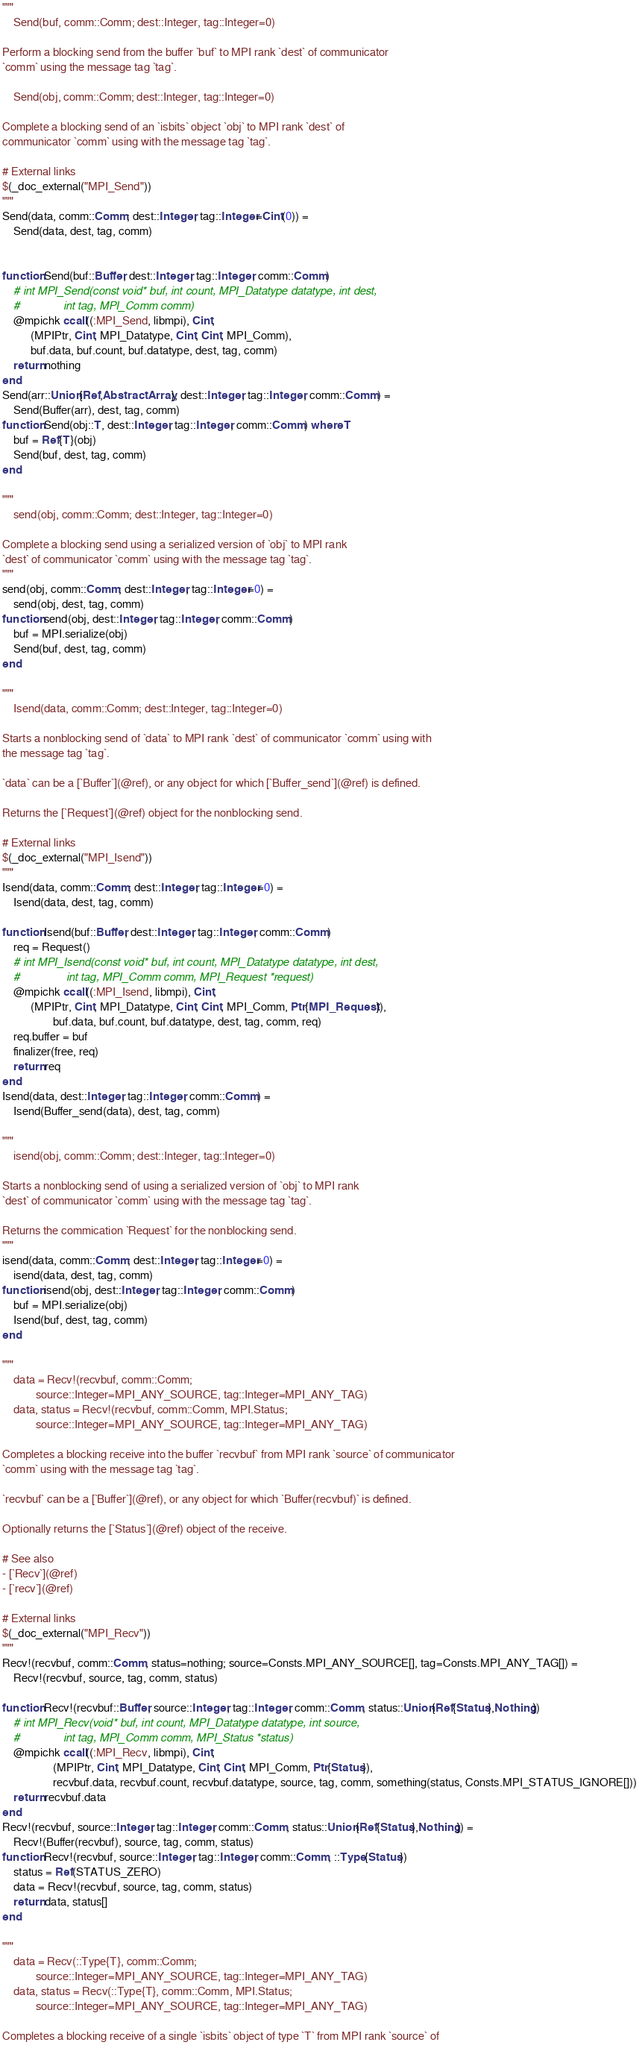Convert code to text. <code><loc_0><loc_0><loc_500><loc_500><_Julia_>
"""
    Send(buf, comm::Comm; dest::Integer, tag::Integer=0)

Perform a blocking send from the buffer `buf` to MPI rank `dest` of communicator
`comm` using the message tag `tag`.

    Send(obj, comm::Comm; dest::Integer, tag::Integer=0)

Complete a blocking send of an `isbits` object `obj` to MPI rank `dest` of
communicator `comm` using with the message tag `tag`.

# External links
$(_doc_external("MPI_Send"))
"""
Send(data, comm::Comm; dest::Integer, tag::Integer=Cint(0)) =
    Send(data, dest, tag, comm)


function Send(buf::Buffer, dest::Integer, tag::Integer, comm::Comm)
    # int MPI_Send(const void* buf, int count, MPI_Datatype datatype, int dest,
    #              int tag, MPI_Comm comm)
    @mpichk ccall((:MPI_Send, libmpi), Cint,
          (MPIPtr, Cint, MPI_Datatype, Cint, Cint, MPI_Comm),
          buf.data, buf.count, buf.datatype, dest, tag, comm)
    return nothing
end
Send(arr::Union{Ref,AbstractArray}, dest::Integer, tag::Integer, comm::Comm) =
    Send(Buffer(arr), dest, tag, comm)
function Send(obj::T, dest::Integer, tag::Integer, comm::Comm) where T
    buf = Ref{T}(obj)
    Send(buf, dest, tag, comm)
end

"""
    send(obj, comm::Comm; dest::Integer, tag::Integer=0)

Complete a blocking send using a serialized version of `obj` to MPI rank
`dest` of communicator `comm` using with the message tag `tag`.
"""
send(obj, comm::Comm; dest::Integer, tag::Integer=0) =
    send(obj, dest, tag, comm)
function send(obj, dest::Integer, tag::Integer, comm::Comm)
    buf = MPI.serialize(obj)
    Send(buf, dest, tag, comm)
end

"""
    Isend(data, comm::Comm; dest::Integer, tag::Integer=0)

Starts a nonblocking send of `data` to MPI rank `dest` of communicator `comm` using with
the message tag `tag`.

`data` can be a [`Buffer`](@ref), or any object for which [`Buffer_send`](@ref) is defined.

Returns the [`Request`](@ref) object for the nonblocking send.

# External links
$(_doc_external("MPI_Isend"))
"""
Isend(data, comm::Comm; dest::Integer, tag::Integer=0) =
    Isend(data, dest, tag, comm)

function Isend(buf::Buffer, dest::Integer, tag::Integer, comm::Comm)
    req = Request()
    # int MPI_Isend(const void* buf, int count, MPI_Datatype datatype, int dest,
    #               int tag, MPI_Comm comm, MPI_Request *request)
    @mpichk ccall((:MPI_Isend, libmpi), Cint,
          (MPIPtr, Cint, MPI_Datatype, Cint, Cint, MPI_Comm, Ptr{MPI_Request}),
                  buf.data, buf.count, buf.datatype, dest, tag, comm, req)
    req.buffer = buf
    finalizer(free, req)
    return req
end
Isend(data, dest::Integer, tag::Integer, comm::Comm) =
    Isend(Buffer_send(data), dest, tag, comm)

"""
    isend(obj, comm::Comm; dest::Integer, tag::Integer=0)

Starts a nonblocking send of using a serialized version of `obj` to MPI rank
`dest` of communicator `comm` using with the message tag `tag`.

Returns the commication `Request` for the nonblocking send.
"""
isend(data, comm::Comm; dest::Integer, tag::Integer=0) =
    isend(data, dest, tag, comm)
function isend(obj, dest::Integer, tag::Integer, comm::Comm)
    buf = MPI.serialize(obj)
    Isend(buf, dest, tag, comm)
end

"""
    data = Recv!(recvbuf, comm::Comm;
            source::Integer=MPI_ANY_SOURCE, tag::Integer=MPI_ANY_TAG)
    data, status = Recv!(recvbuf, comm::Comm, MPI.Status;
            source::Integer=MPI_ANY_SOURCE, tag::Integer=MPI_ANY_TAG)

Completes a blocking receive into the buffer `recvbuf` from MPI rank `source` of communicator
`comm` using with the message tag `tag`.

`recvbuf` can be a [`Buffer`](@ref), or any object for which `Buffer(recvbuf)` is defined.

Optionally returns the [`Status`](@ref) object of the receive.

# See also
- [`Recv`](@ref)
- [`recv`](@ref)

# External links
$(_doc_external("MPI_Recv"))
"""
Recv!(recvbuf, comm::Comm, status=nothing; source=Consts.MPI_ANY_SOURCE[], tag=Consts.MPI_ANY_TAG[]) =
    Recv!(recvbuf, source, tag, comm, status)

function Recv!(recvbuf::Buffer, source::Integer, tag::Integer, comm::Comm, status::Union{Ref{Status},Nothing})
    # int MPI_Recv(void* buf, int count, MPI_Datatype datatype, int source,
    #              int tag, MPI_Comm comm, MPI_Status *status)
    @mpichk ccall((:MPI_Recv, libmpi), Cint,
                  (MPIPtr, Cint, MPI_Datatype, Cint, Cint, MPI_Comm, Ptr{Status}),
                  recvbuf.data, recvbuf.count, recvbuf.datatype, source, tag, comm, something(status, Consts.MPI_STATUS_IGNORE[]))
    return recvbuf.data
end
Recv!(recvbuf, source::Integer, tag::Integer, comm::Comm, status::Union{Ref{Status},Nothing}) =
    Recv!(Buffer(recvbuf), source, tag, comm, status)
function Recv!(recvbuf, source::Integer, tag::Integer, comm::Comm, ::Type{Status})
    status = Ref(STATUS_ZERO)
    data = Recv!(recvbuf, source, tag, comm, status)
    return data, status[]
end

"""
    data = Recv(::Type{T}, comm::Comm;
            source::Integer=MPI_ANY_SOURCE, tag::Integer=MPI_ANY_TAG)
    data, status = Recv(::Type{T}, comm::Comm, MPI.Status;
            source::Integer=MPI_ANY_SOURCE, tag::Integer=MPI_ANY_TAG)

Completes a blocking receive of a single `isbits` object of type `T` from MPI rank `source` of</code> 